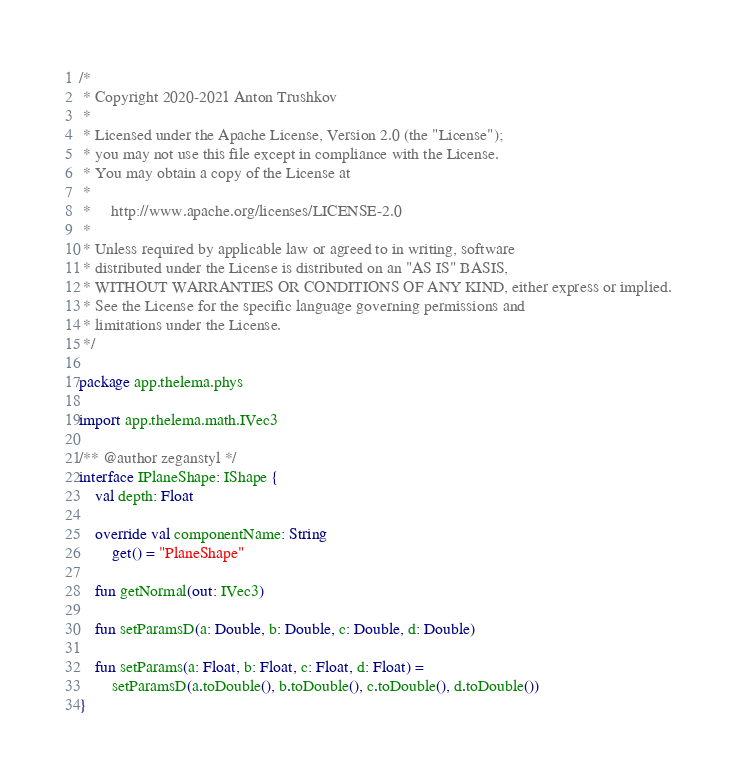<code> <loc_0><loc_0><loc_500><loc_500><_Kotlin_>/*
 * Copyright 2020-2021 Anton Trushkov
 *
 * Licensed under the Apache License, Version 2.0 (the "License");
 * you may not use this file except in compliance with the License.
 * You may obtain a copy of the License at
 *
 *     http://www.apache.org/licenses/LICENSE-2.0
 *
 * Unless required by applicable law or agreed to in writing, software
 * distributed under the License is distributed on an "AS IS" BASIS,
 * WITHOUT WARRANTIES OR CONDITIONS OF ANY KIND, either express or implied.
 * See the License for the specific language governing permissions and
 * limitations under the License.
 */

package app.thelema.phys

import app.thelema.math.IVec3

/** @author zeganstyl */
interface IPlaneShape: IShape {
    val depth: Float

    override val componentName: String
        get() = "PlaneShape"

    fun getNormal(out: IVec3)

    fun setParamsD(a: Double, b: Double, c: Double, d: Double)

    fun setParams(a: Float, b: Float, c: Float, d: Float) =
        setParamsD(a.toDouble(), b.toDouble(), c.toDouble(), d.toDouble())
}</code> 